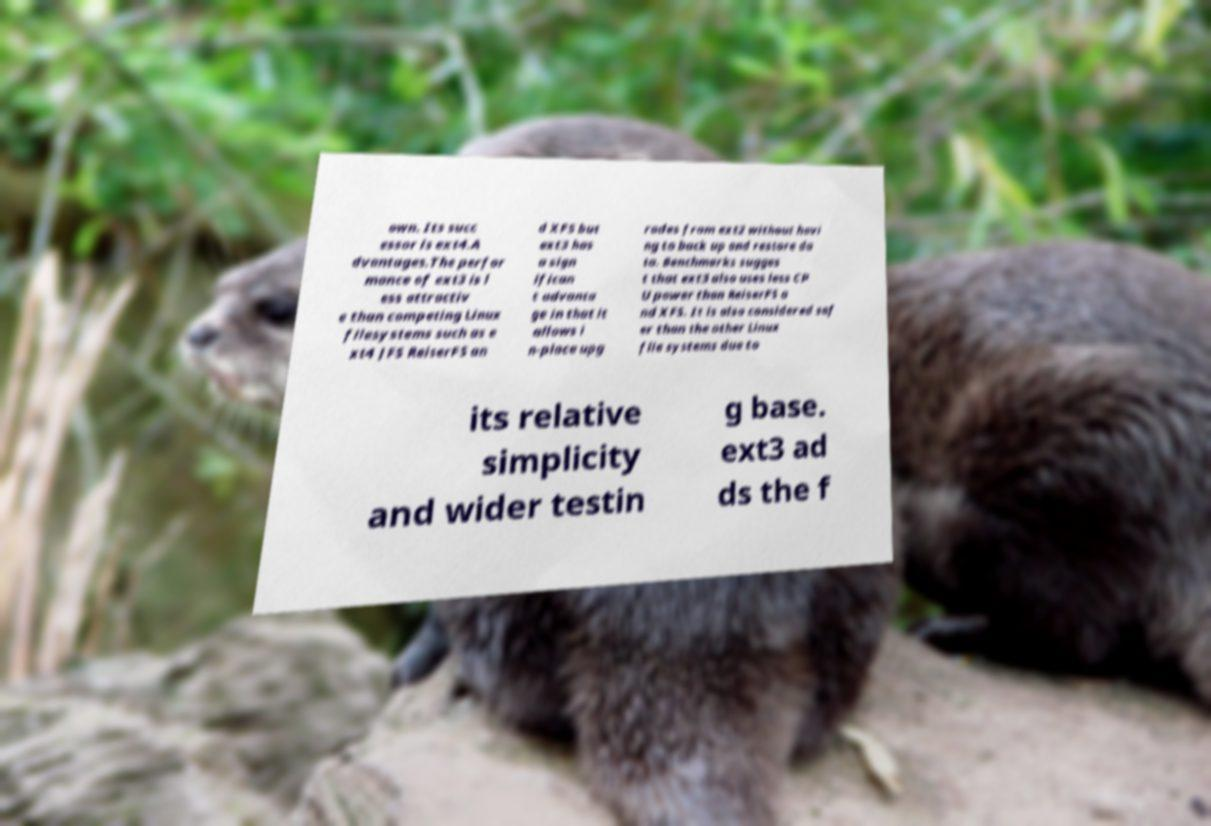Can you read and provide the text displayed in the image?This photo seems to have some interesting text. Can you extract and type it out for me? own. Its succ essor is ext4.A dvantages.The perfor mance of ext3 is l ess attractiv e than competing Linux filesystems such as e xt4 JFS ReiserFS an d XFS but ext3 has a sign ifican t advanta ge in that it allows i n-place upg rades from ext2 without havi ng to back up and restore da ta. Benchmarks sugges t that ext3 also uses less CP U power than ReiserFS a nd XFS. It is also considered saf er than the other Linux file systems due to its relative simplicity and wider testin g base. ext3 ad ds the f 